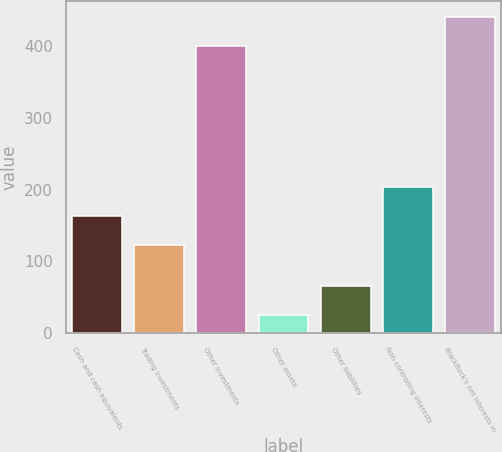<chart> <loc_0><loc_0><loc_500><loc_500><bar_chart><fcel>Cash and cash equivalents<fcel>Trading investments<fcel>Other investments<fcel>Other assets<fcel>Other liabilities<fcel>Non-controlling interests<fcel>BlackRock's net interests in<nl><fcel>163.5<fcel>123<fcel>401<fcel>25<fcel>65.5<fcel>204<fcel>441.5<nl></chart> 